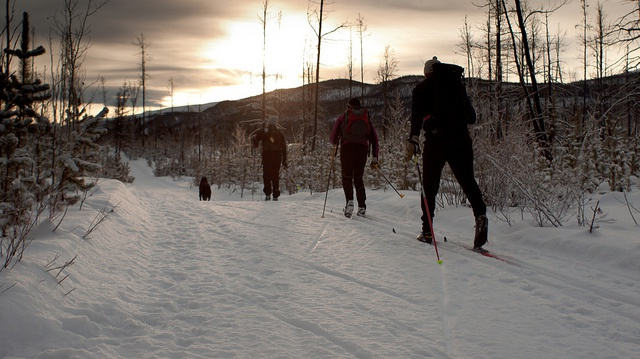Describe the objects in this image and their specific colors. I can see people in black, gray, and maroon tones, people in black, gray, and maroon tones, backpack in black, maroon, and olive tones, people in black, gray, and maroon tones, and backpack in black and maroon tones in this image. 